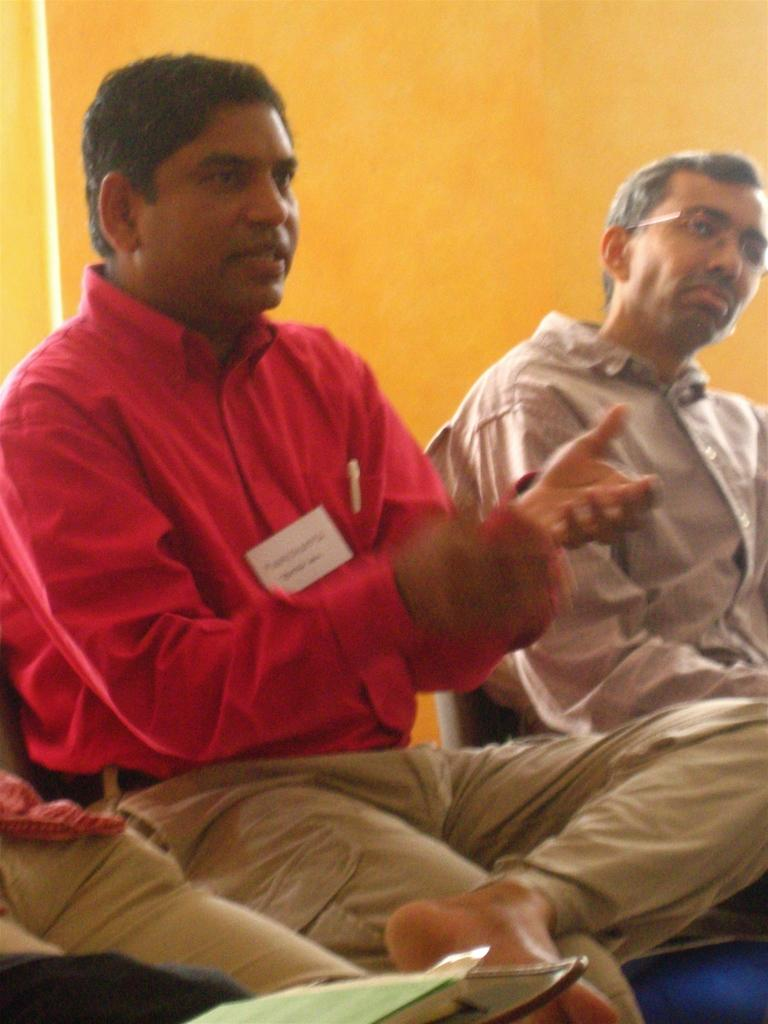How many people are in the image? There are two men in the image. What is the man in the red shirt doing? The man in the red shirt is talking. What color is the shirt of one of the men? One of the men is wearing a red shirt. What can be seen in the background of the image? There is a yellow wall in the background of the image. What type of bushes can be seen in the image? There are no bushes present in the image. What instrument is the band playing in the background? There is no band present in the image, so it is not possible to determine what, if any, instruments might be played. 